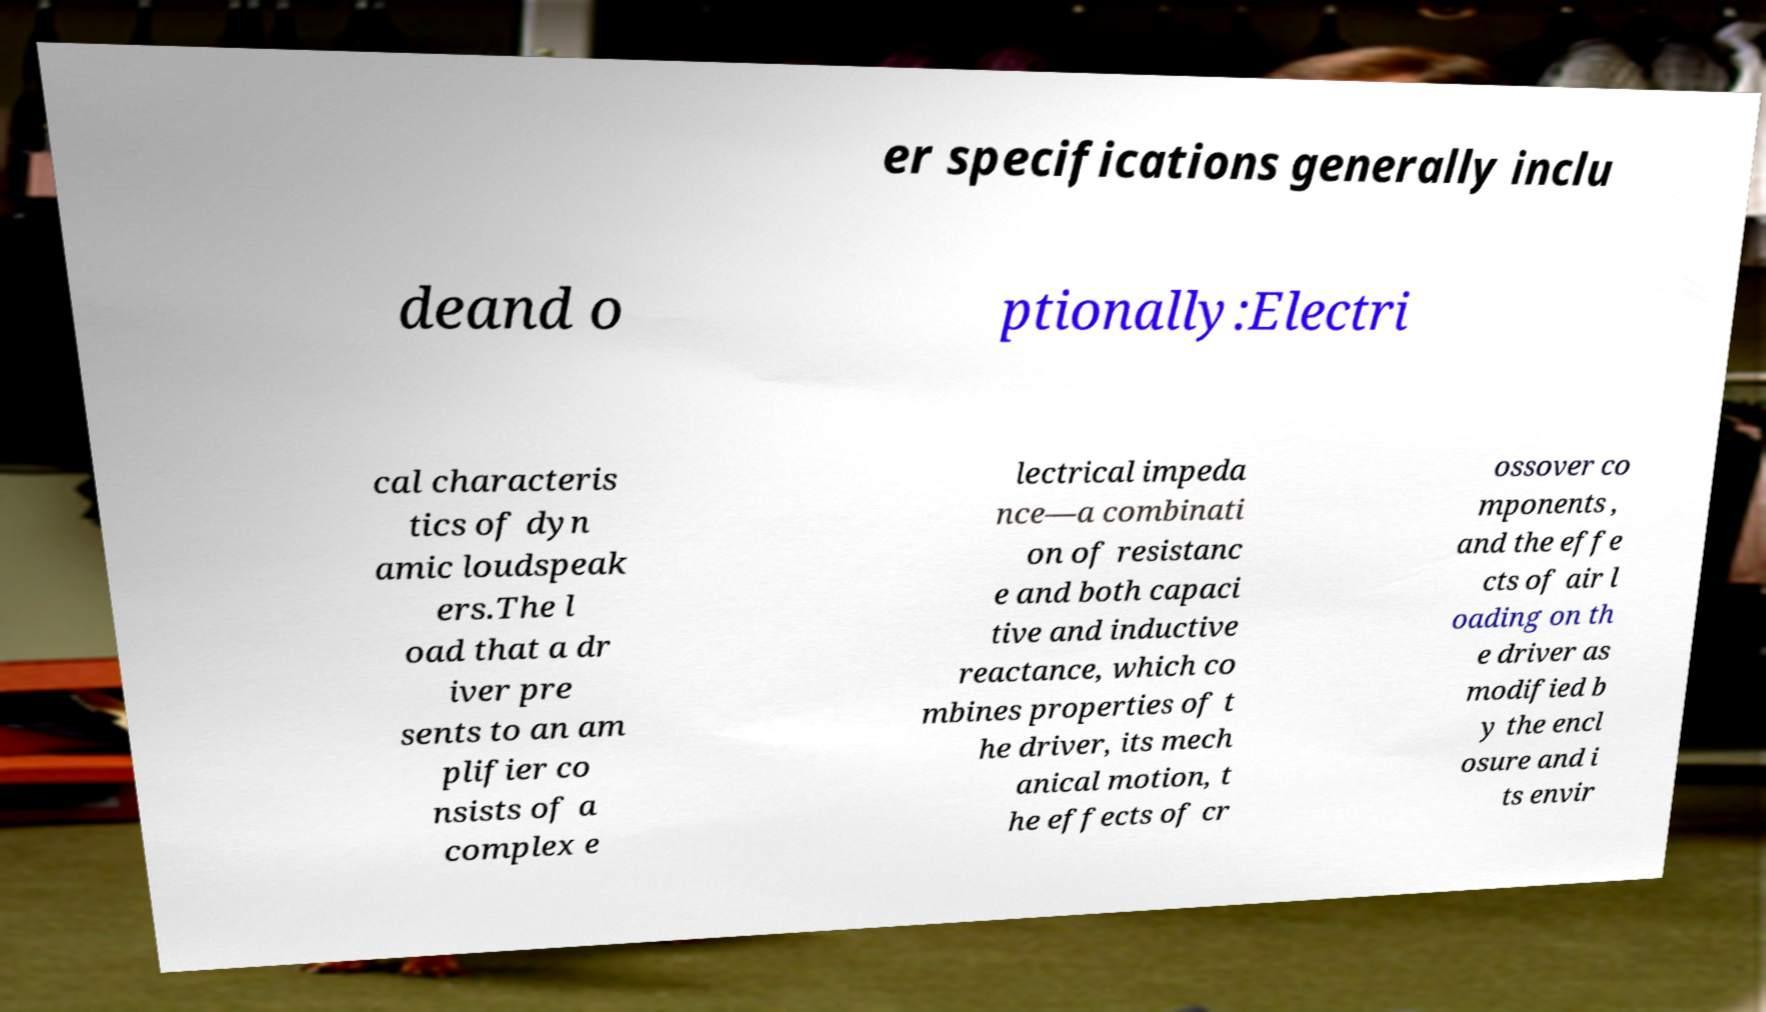Please read and relay the text visible in this image. What does it say? er specifications generally inclu deand o ptionally:Electri cal characteris tics of dyn amic loudspeak ers.The l oad that a dr iver pre sents to an am plifier co nsists of a complex e lectrical impeda nce—a combinati on of resistanc e and both capaci tive and inductive reactance, which co mbines properties of t he driver, its mech anical motion, t he effects of cr ossover co mponents , and the effe cts of air l oading on th e driver as modified b y the encl osure and i ts envir 